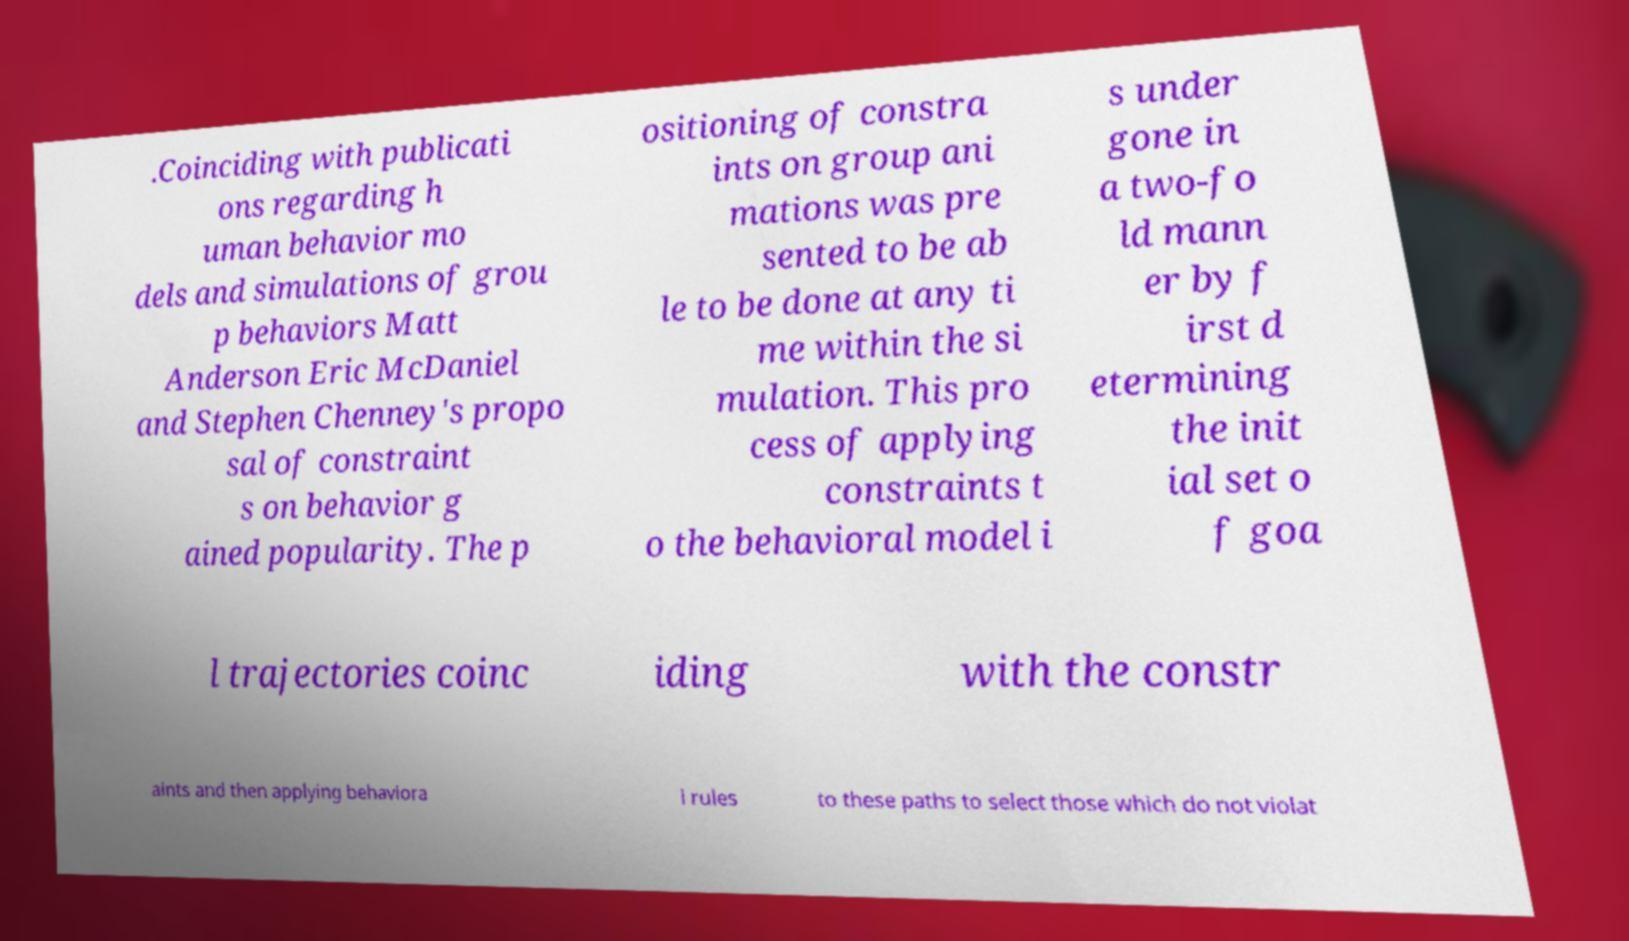Could you assist in decoding the text presented in this image and type it out clearly? .Coinciding with publicati ons regarding h uman behavior mo dels and simulations of grou p behaviors Matt Anderson Eric McDaniel and Stephen Chenney's propo sal of constraint s on behavior g ained popularity. The p ositioning of constra ints on group ani mations was pre sented to be ab le to be done at any ti me within the si mulation. This pro cess of applying constraints t o the behavioral model i s under gone in a two-fo ld mann er by f irst d etermining the init ial set o f goa l trajectories coinc iding with the constr aints and then applying behaviora l rules to these paths to select those which do not violat 